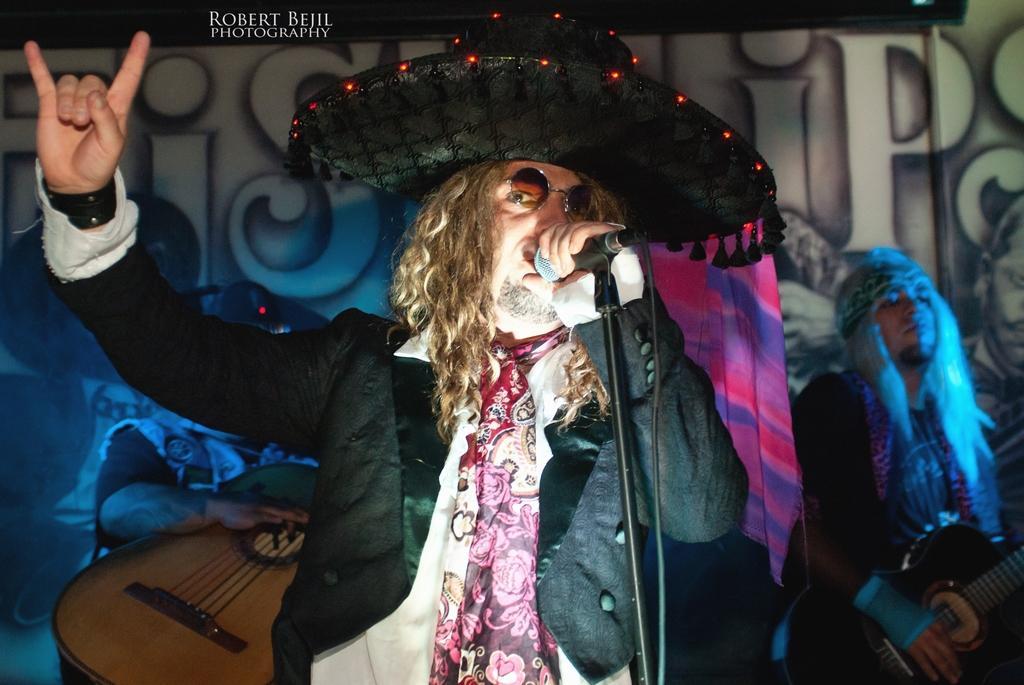How would you summarize this image in a sentence or two? In the given image we can see a man holding microphone in his hands and wearing a cap is performing. Back of him there are other people who are holding guitar in their hands. This is a watermark. 